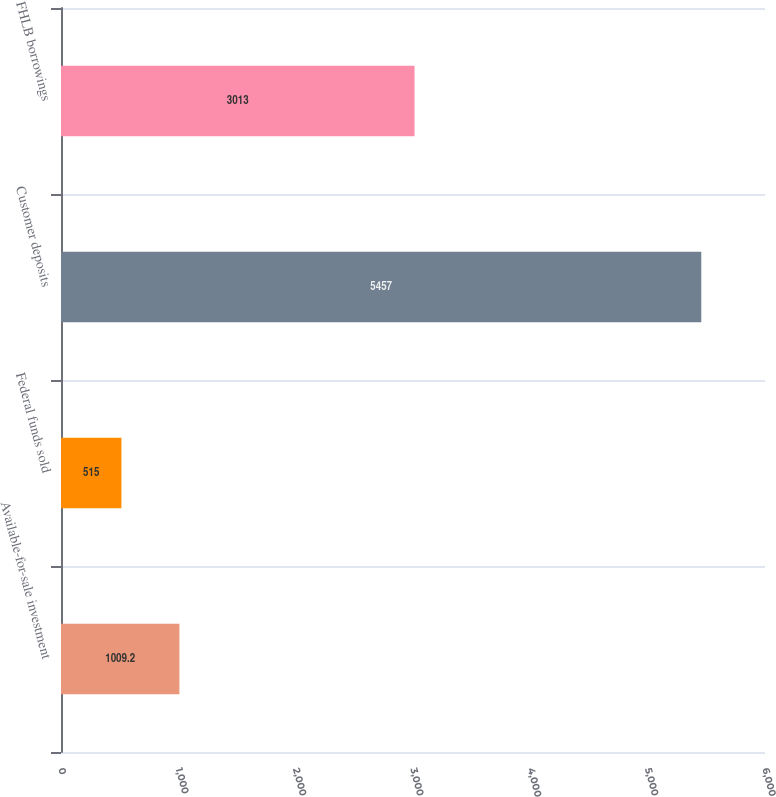Convert chart. <chart><loc_0><loc_0><loc_500><loc_500><bar_chart><fcel>Available-for-sale investment<fcel>Federal funds sold<fcel>Customer deposits<fcel>FHLB borrowings<nl><fcel>1009.2<fcel>515<fcel>5457<fcel>3013<nl></chart> 